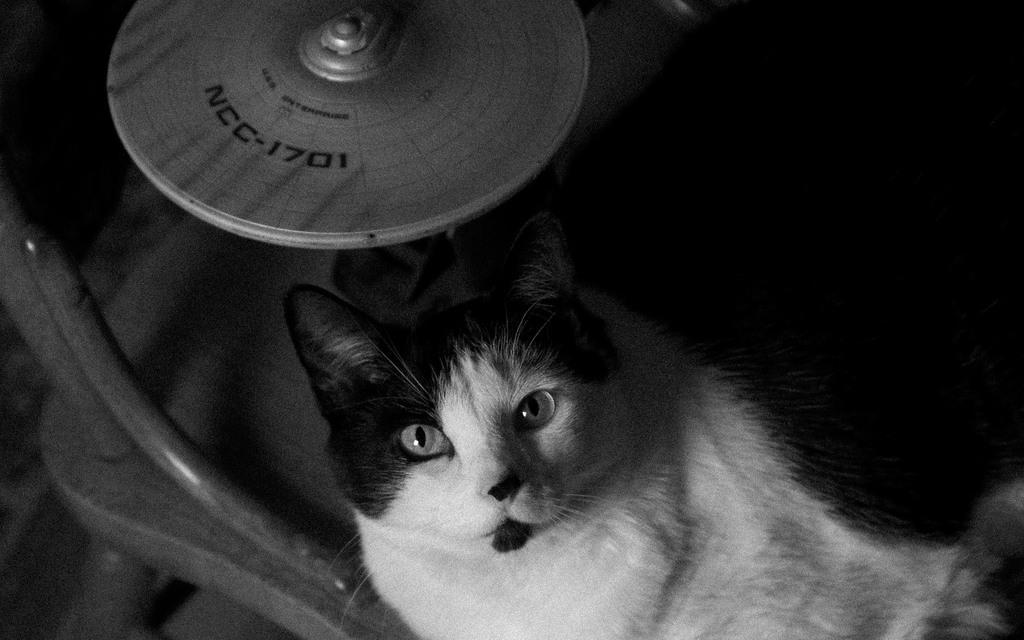Could you give a brief overview of what you see in this image? At the bottom of the image we can see a cat. On the left there is a chair. At the top we can see a disc. 